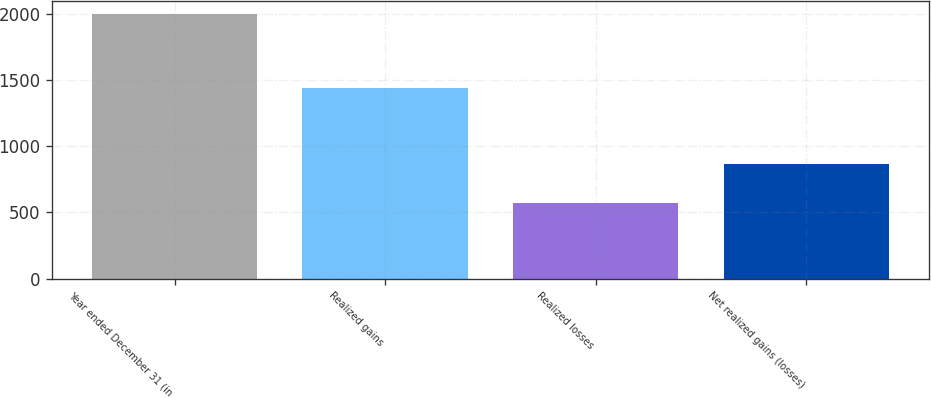Convert chart. <chart><loc_0><loc_0><loc_500><loc_500><bar_chart><fcel>Year ended December 31 (in<fcel>Realized gains<fcel>Realized losses<fcel>Net realized gains (losses)<nl><fcel>2001<fcel>1438<fcel>572<fcel>866<nl></chart> 